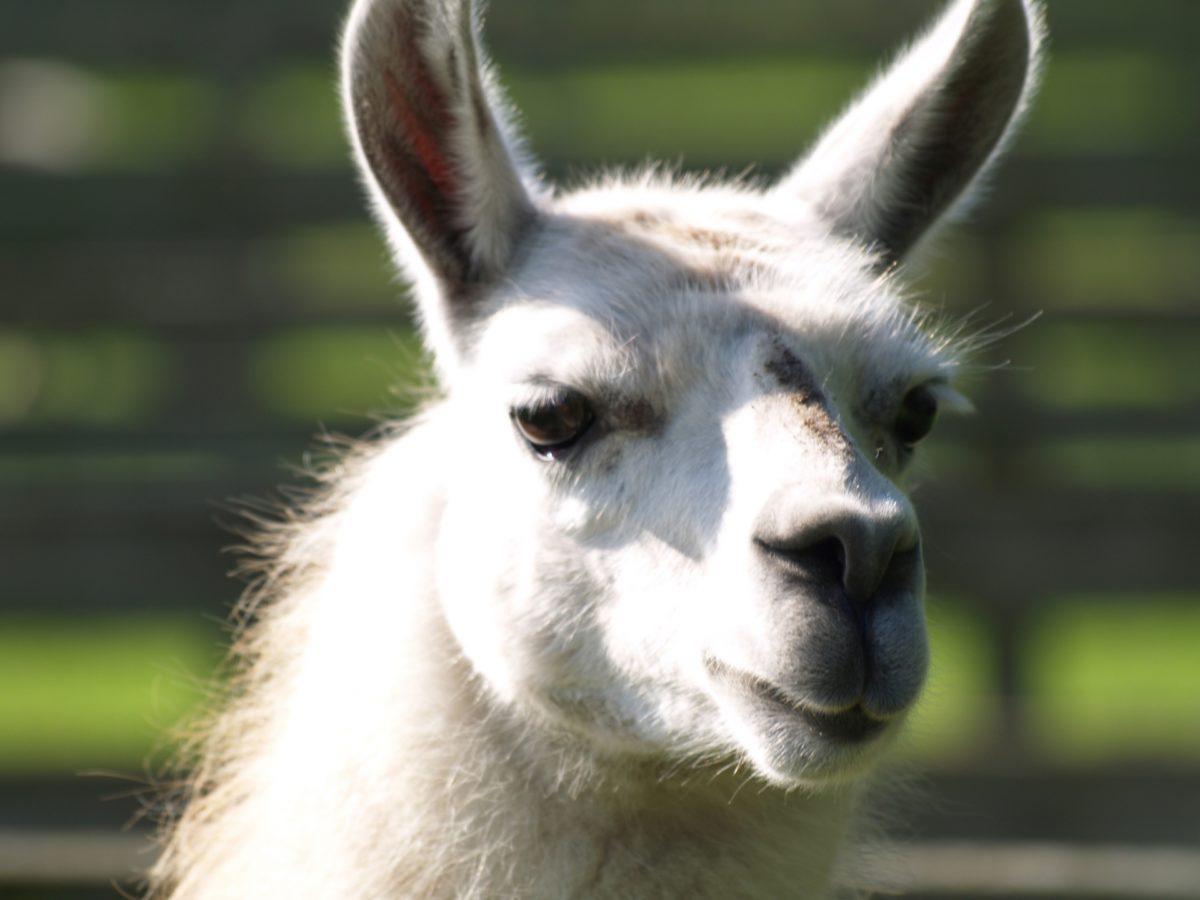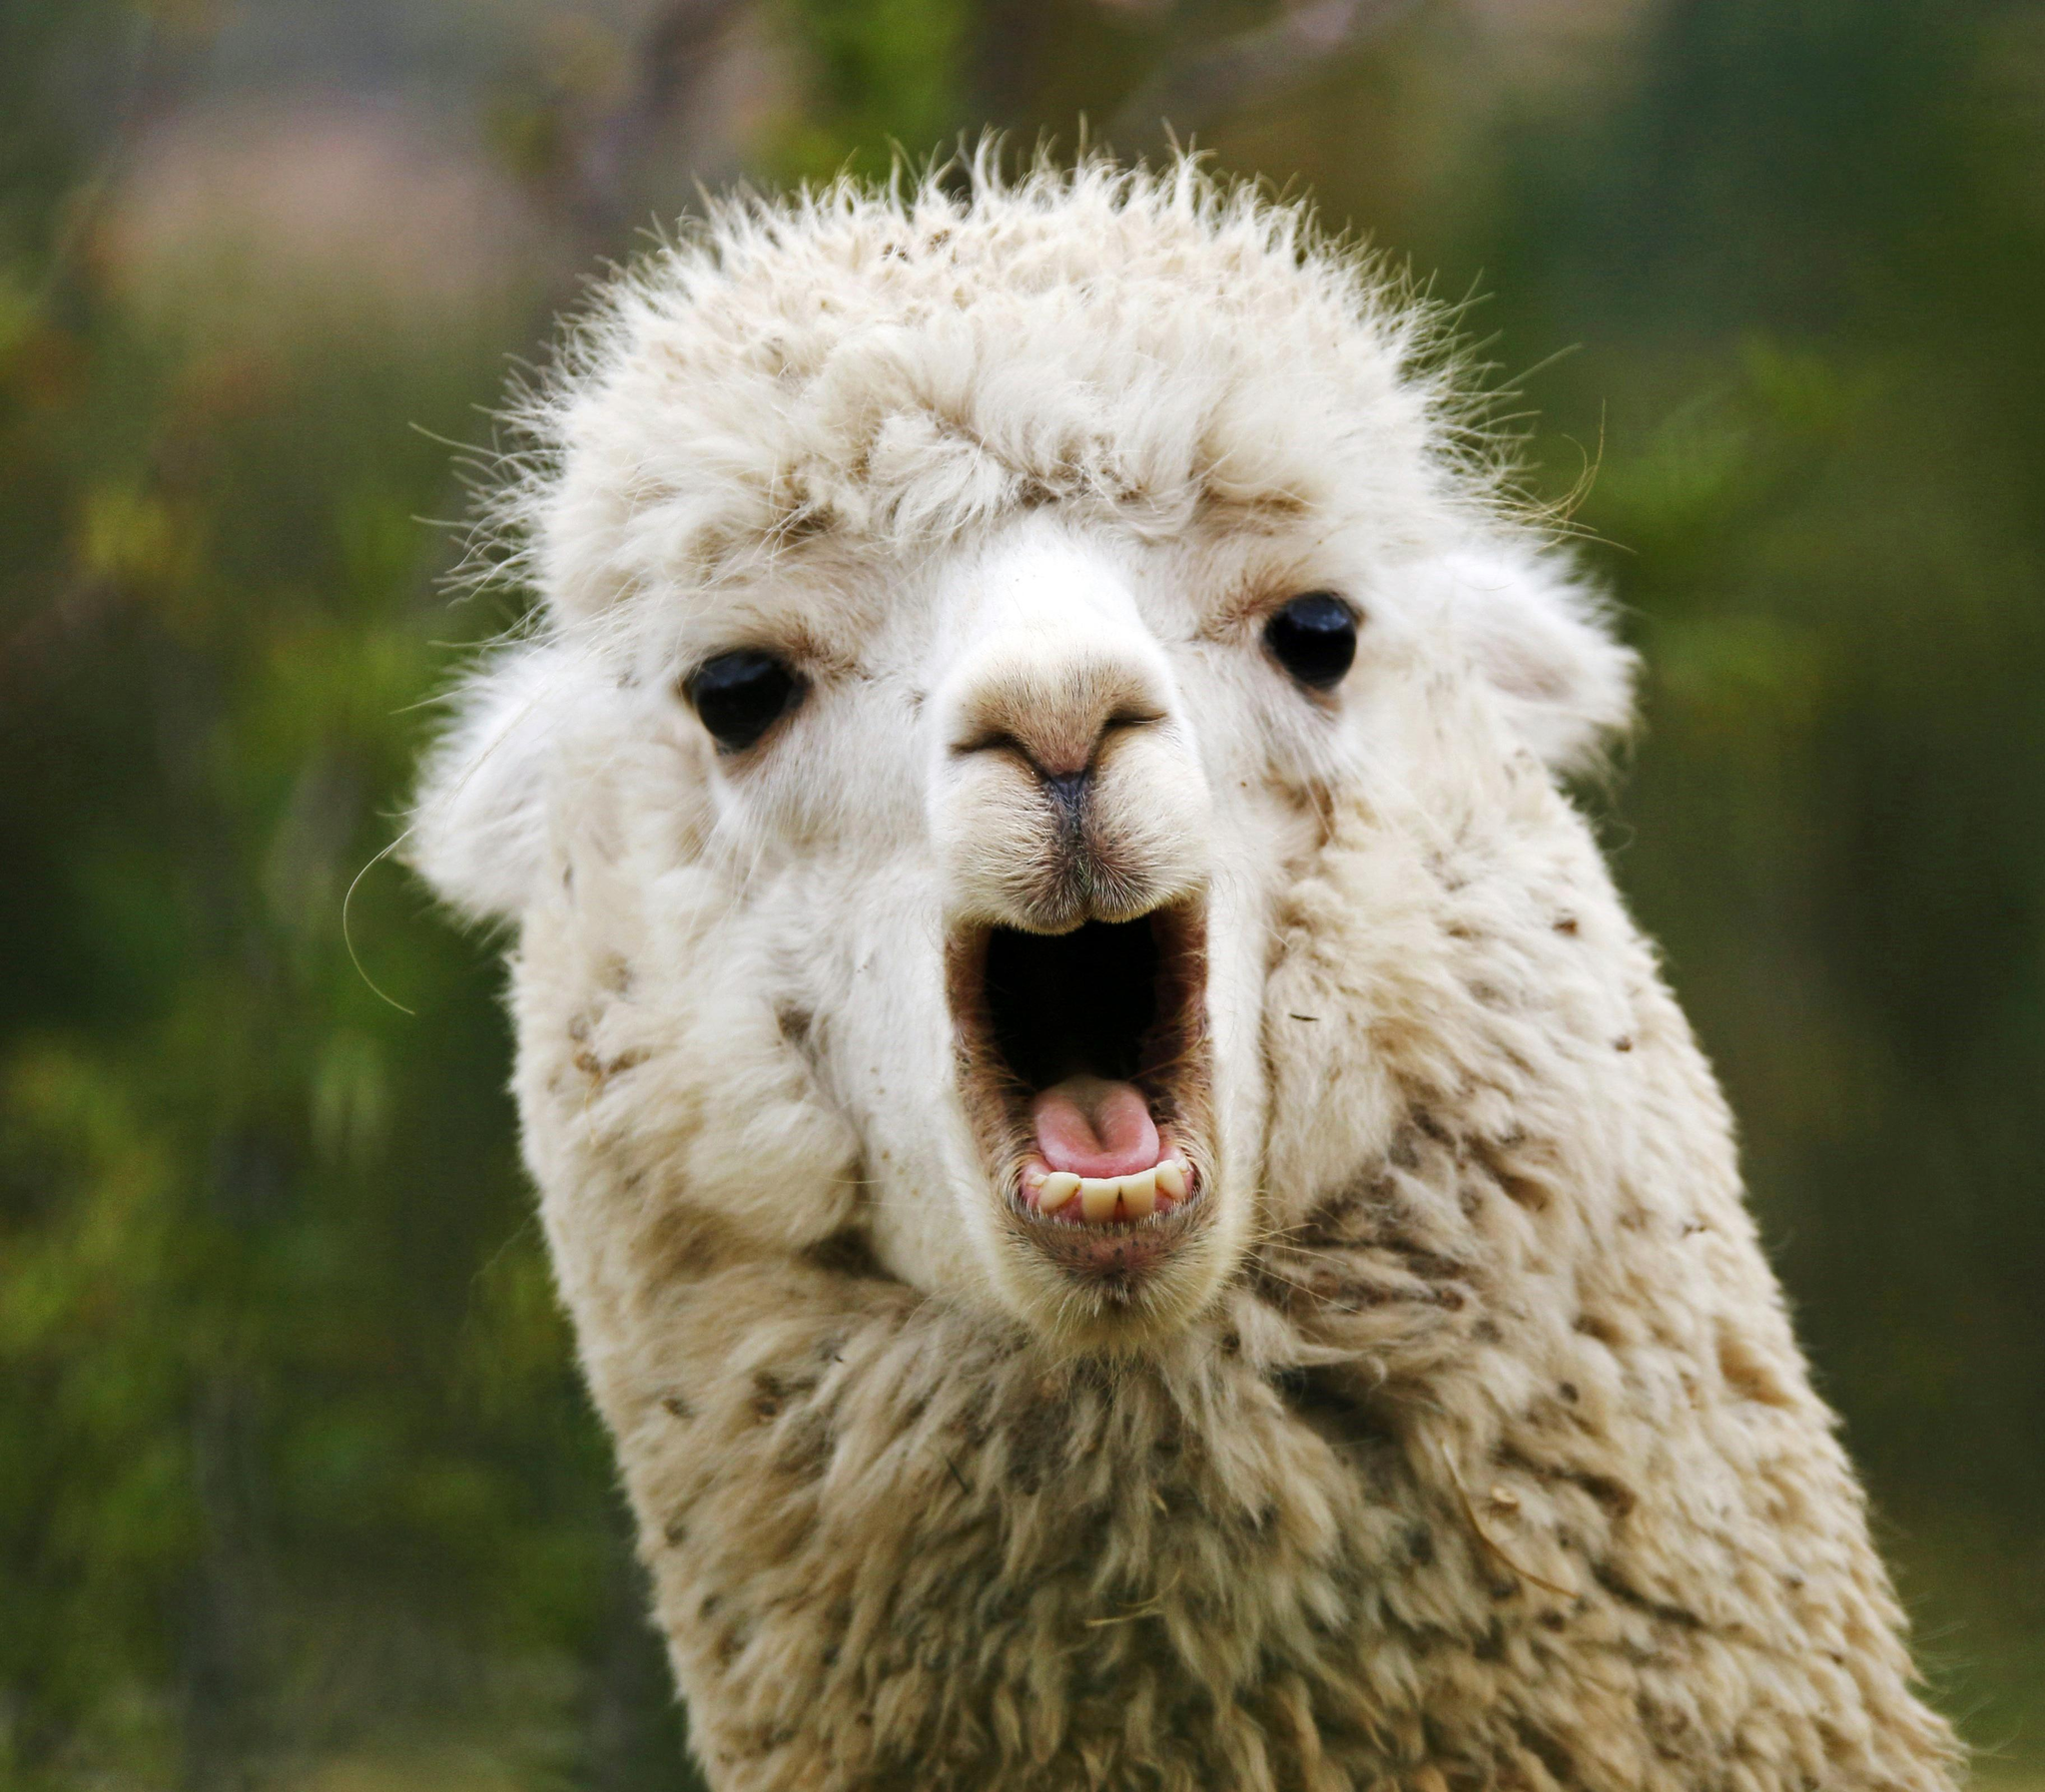The first image is the image on the left, the second image is the image on the right. Considering the images on both sides, is "there is a llama  with it's mouth open wide showing it's tongue and teeth" valid? Answer yes or no. Yes. 